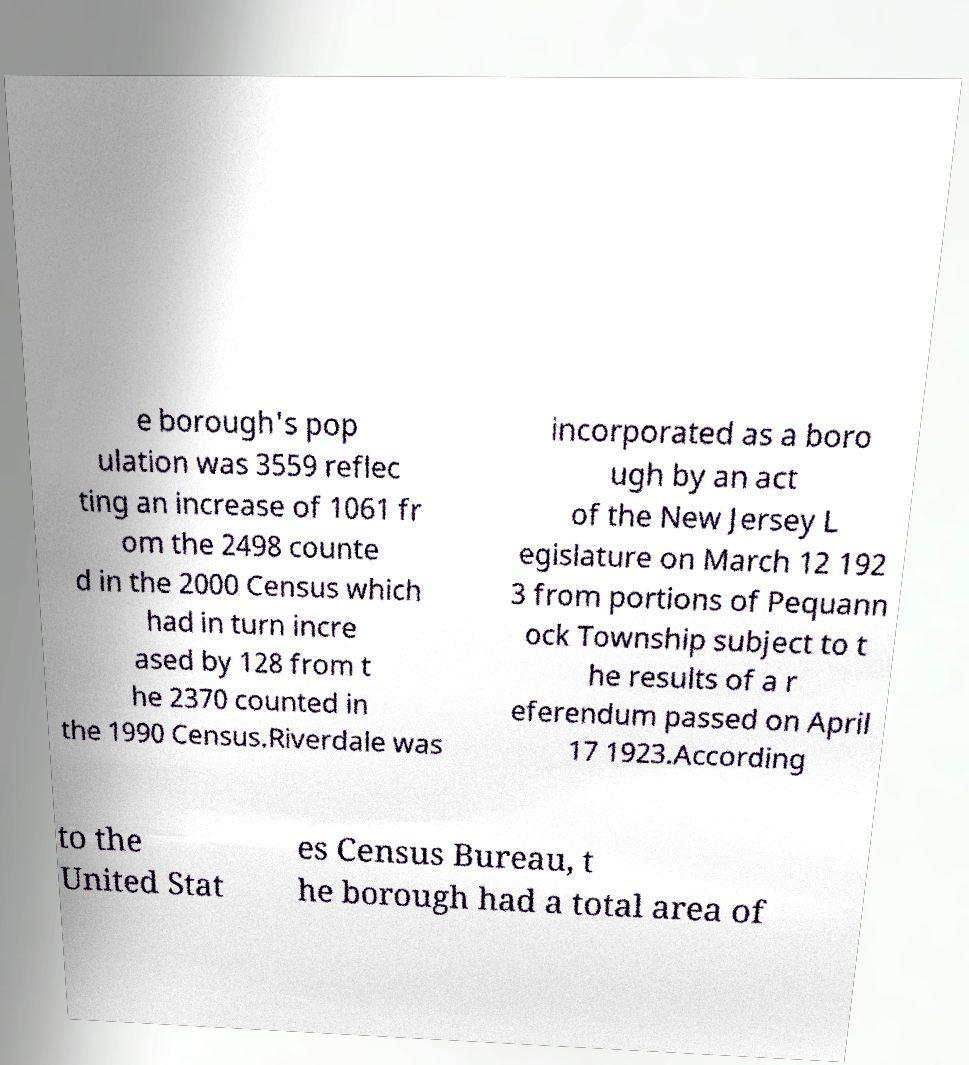Can you accurately transcribe the text from the provided image for me? e borough's pop ulation was 3559 reflec ting an increase of 1061 fr om the 2498 counte d in the 2000 Census which had in turn incre ased by 128 from t he 2370 counted in the 1990 Census.Riverdale was incorporated as a boro ugh by an act of the New Jersey L egislature on March 12 192 3 from portions of Pequann ock Township subject to t he results of a r eferendum passed on April 17 1923.According to the United Stat es Census Bureau, t he borough had a total area of 